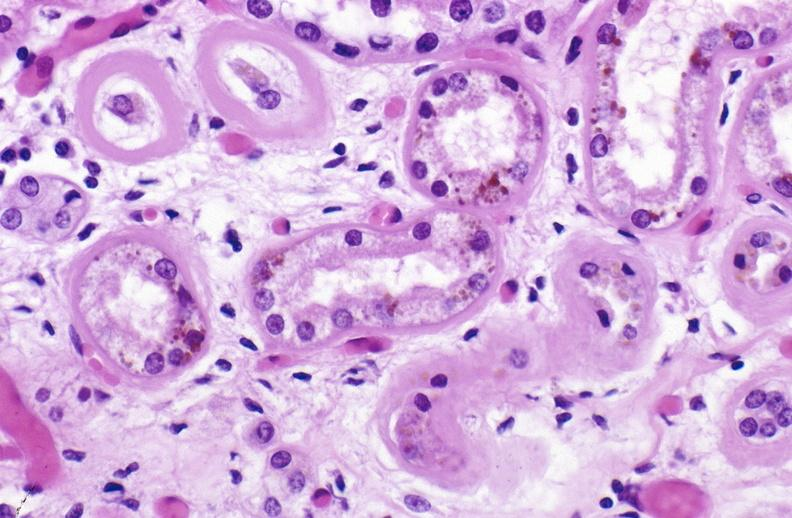what is present?
Answer the question using a single word or phrase. Urinary 